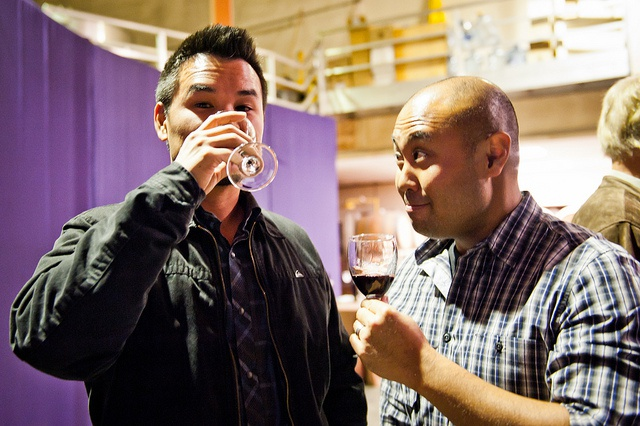Describe the objects in this image and their specific colors. I can see people in purple, black, gray, darkgray, and ivory tones, people in purple, lightgray, black, maroon, and tan tones, people in purple, tan, and beige tones, wine glass in purple, white, black, and tan tones, and wine glass in purple, tan, violet, lightgray, and salmon tones in this image. 